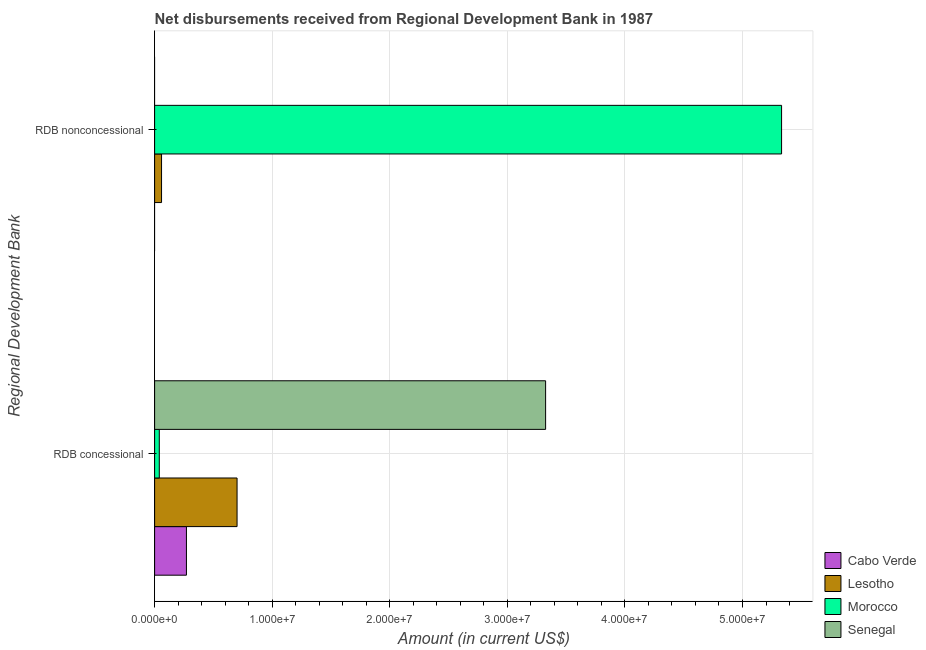How many groups of bars are there?
Make the answer very short. 2. Are the number of bars per tick equal to the number of legend labels?
Your answer should be compact. No. Are the number of bars on each tick of the Y-axis equal?
Ensure brevity in your answer.  No. How many bars are there on the 2nd tick from the bottom?
Offer a very short reply. 2. What is the label of the 2nd group of bars from the top?
Your answer should be very brief. RDB concessional. Across all countries, what is the maximum net concessional disbursements from rdb?
Ensure brevity in your answer.  3.33e+07. Across all countries, what is the minimum net concessional disbursements from rdb?
Provide a succinct answer. 3.99e+05. In which country was the net concessional disbursements from rdb maximum?
Ensure brevity in your answer.  Senegal. What is the total net concessional disbursements from rdb in the graph?
Offer a terse response. 4.34e+07. What is the difference between the net non concessional disbursements from rdb in Lesotho and that in Morocco?
Your answer should be very brief. -5.27e+07. What is the difference between the net non concessional disbursements from rdb in Cabo Verde and the net concessional disbursements from rdb in Senegal?
Keep it short and to the point. -3.33e+07. What is the average net concessional disbursements from rdb per country?
Ensure brevity in your answer.  1.08e+07. What is the difference between the net non concessional disbursements from rdb and net concessional disbursements from rdb in Morocco?
Keep it short and to the point. 5.29e+07. What is the ratio of the net concessional disbursements from rdb in Cabo Verde to that in Morocco?
Provide a succinct answer. 6.78. Is the net concessional disbursements from rdb in Lesotho less than that in Senegal?
Ensure brevity in your answer.  Yes. In how many countries, is the net non concessional disbursements from rdb greater than the average net non concessional disbursements from rdb taken over all countries?
Give a very brief answer. 1. How many countries are there in the graph?
Keep it short and to the point. 4. What is the difference between two consecutive major ticks on the X-axis?
Your answer should be compact. 1.00e+07. Does the graph contain any zero values?
Keep it short and to the point. Yes. Does the graph contain grids?
Offer a terse response. Yes. Where does the legend appear in the graph?
Make the answer very short. Bottom right. How many legend labels are there?
Offer a terse response. 4. What is the title of the graph?
Keep it short and to the point. Net disbursements received from Regional Development Bank in 1987. Does "Low & middle income" appear as one of the legend labels in the graph?
Keep it short and to the point. No. What is the label or title of the X-axis?
Give a very brief answer. Amount (in current US$). What is the label or title of the Y-axis?
Your answer should be compact. Regional Development Bank. What is the Amount (in current US$) in Cabo Verde in RDB concessional?
Keep it short and to the point. 2.71e+06. What is the Amount (in current US$) in Lesotho in RDB concessional?
Keep it short and to the point. 7.01e+06. What is the Amount (in current US$) of Morocco in RDB concessional?
Provide a succinct answer. 3.99e+05. What is the Amount (in current US$) of Senegal in RDB concessional?
Your answer should be compact. 3.33e+07. What is the Amount (in current US$) of Lesotho in RDB nonconcessional?
Your response must be concise. 5.90e+05. What is the Amount (in current US$) of Morocco in RDB nonconcessional?
Provide a succinct answer. 5.33e+07. What is the Amount (in current US$) in Senegal in RDB nonconcessional?
Your response must be concise. 0. Across all Regional Development Bank, what is the maximum Amount (in current US$) in Cabo Verde?
Offer a very short reply. 2.71e+06. Across all Regional Development Bank, what is the maximum Amount (in current US$) of Lesotho?
Keep it short and to the point. 7.01e+06. Across all Regional Development Bank, what is the maximum Amount (in current US$) in Morocco?
Offer a very short reply. 5.33e+07. Across all Regional Development Bank, what is the maximum Amount (in current US$) of Senegal?
Provide a succinct answer. 3.33e+07. Across all Regional Development Bank, what is the minimum Amount (in current US$) of Cabo Verde?
Your answer should be very brief. 0. Across all Regional Development Bank, what is the minimum Amount (in current US$) in Lesotho?
Keep it short and to the point. 5.90e+05. Across all Regional Development Bank, what is the minimum Amount (in current US$) in Morocco?
Keep it short and to the point. 3.99e+05. What is the total Amount (in current US$) in Cabo Verde in the graph?
Provide a short and direct response. 2.71e+06. What is the total Amount (in current US$) in Lesotho in the graph?
Offer a terse response. 7.60e+06. What is the total Amount (in current US$) in Morocco in the graph?
Make the answer very short. 5.37e+07. What is the total Amount (in current US$) of Senegal in the graph?
Your answer should be compact. 3.33e+07. What is the difference between the Amount (in current US$) in Lesotho in RDB concessional and that in RDB nonconcessional?
Give a very brief answer. 6.42e+06. What is the difference between the Amount (in current US$) of Morocco in RDB concessional and that in RDB nonconcessional?
Offer a terse response. -5.29e+07. What is the difference between the Amount (in current US$) in Cabo Verde in RDB concessional and the Amount (in current US$) in Lesotho in RDB nonconcessional?
Make the answer very short. 2.12e+06. What is the difference between the Amount (in current US$) in Cabo Verde in RDB concessional and the Amount (in current US$) in Morocco in RDB nonconcessional?
Your answer should be very brief. -5.06e+07. What is the difference between the Amount (in current US$) of Lesotho in RDB concessional and the Amount (in current US$) of Morocco in RDB nonconcessional?
Offer a very short reply. -4.63e+07. What is the average Amount (in current US$) of Cabo Verde per Regional Development Bank?
Make the answer very short. 1.35e+06. What is the average Amount (in current US$) in Lesotho per Regional Development Bank?
Your response must be concise. 3.80e+06. What is the average Amount (in current US$) in Morocco per Regional Development Bank?
Offer a very short reply. 2.69e+07. What is the average Amount (in current US$) in Senegal per Regional Development Bank?
Your answer should be compact. 1.66e+07. What is the difference between the Amount (in current US$) in Cabo Verde and Amount (in current US$) in Lesotho in RDB concessional?
Your response must be concise. -4.31e+06. What is the difference between the Amount (in current US$) in Cabo Verde and Amount (in current US$) in Morocco in RDB concessional?
Offer a very short reply. 2.31e+06. What is the difference between the Amount (in current US$) in Cabo Verde and Amount (in current US$) in Senegal in RDB concessional?
Your answer should be very brief. -3.05e+07. What is the difference between the Amount (in current US$) of Lesotho and Amount (in current US$) of Morocco in RDB concessional?
Keep it short and to the point. 6.61e+06. What is the difference between the Amount (in current US$) in Lesotho and Amount (in current US$) in Senegal in RDB concessional?
Make the answer very short. -2.62e+07. What is the difference between the Amount (in current US$) in Morocco and Amount (in current US$) in Senegal in RDB concessional?
Ensure brevity in your answer.  -3.29e+07. What is the difference between the Amount (in current US$) of Lesotho and Amount (in current US$) of Morocco in RDB nonconcessional?
Keep it short and to the point. -5.27e+07. What is the ratio of the Amount (in current US$) of Lesotho in RDB concessional to that in RDB nonconcessional?
Offer a very short reply. 11.89. What is the ratio of the Amount (in current US$) of Morocco in RDB concessional to that in RDB nonconcessional?
Keep it short and to the point. 0.01. What is the difference between the highest and the second highest Amount (in current US$) of Lesotho?
Offer a very short reply. 6.42e+06. What is the difference between the highest and the second highest Amount (in current US$) of Morocco?
Your answer should be very brief. 5.29e+07. What is the difference between the highest and the lowest Amount (in current US$) in Cabo Verde?
Your response must be concise. 2.71e+06. What is the difference between the highest and the lowest Amount (in current US$) in Lesotho?
Provide a short and direct response. 6.42e+06. What is the difference between the highest and the lowest Amount (in current US$) of Morocco?
Give a very brief answer. 5.29e+07. What is the difference between the highest and the lowest Amount (in current US$) of Senegal?
Ensure brevity in your answer.  3.33e+07. 